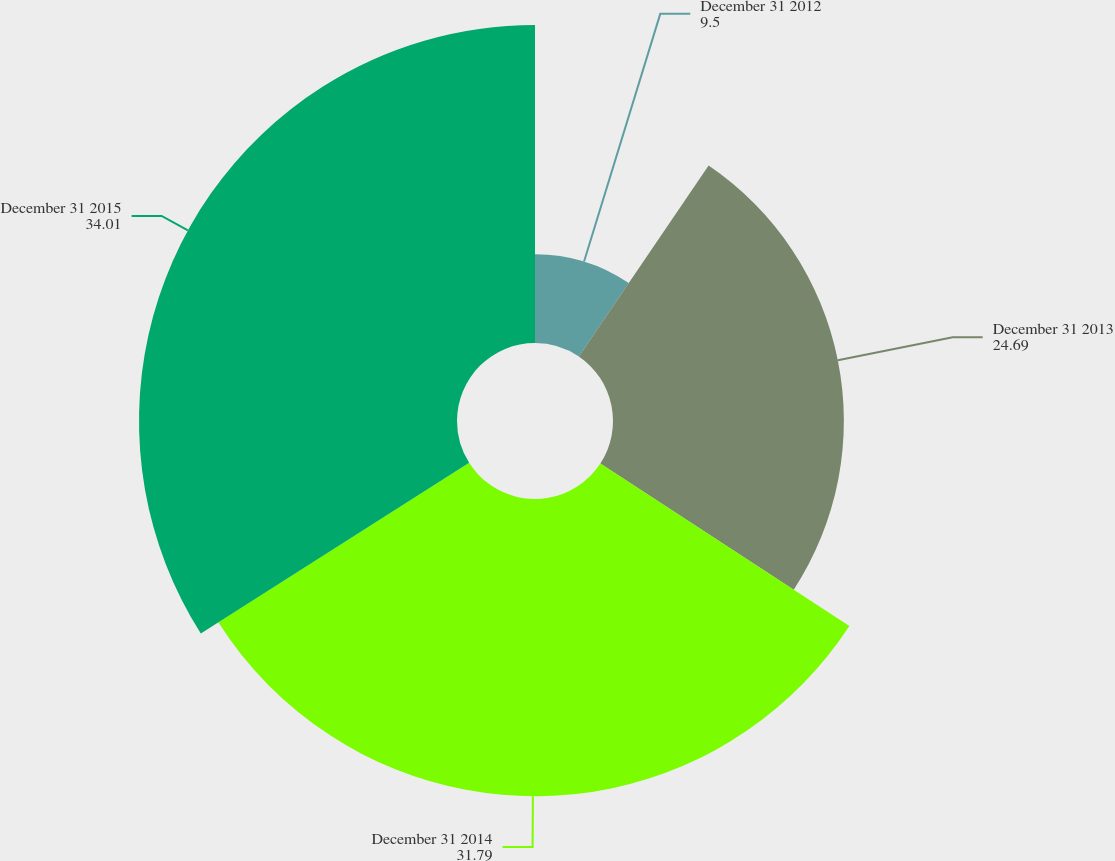Convert chart to OTSL. <chart><loc_0><loc_0><loc_500><loc_500><pie_chart><fcel>December 31 2012<fcel>December 31 2013<fcel>December 31 2014<fcel>December 31 2015<nl><fcel>9.5%<fcel>24.69%<fcel>31.79%<fcel>34.01%<nl></chart> 